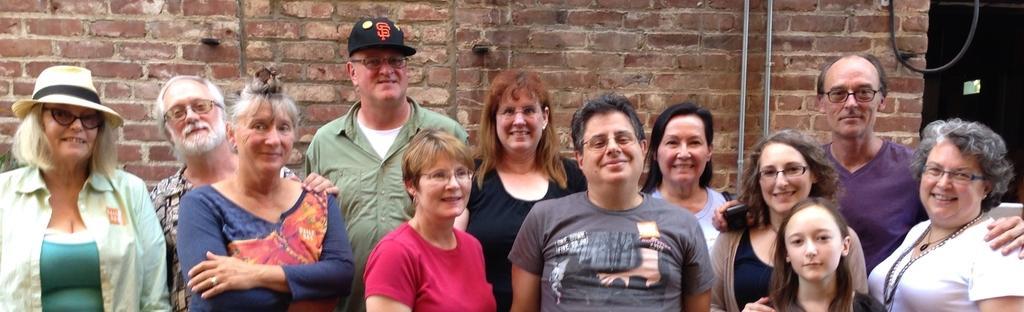How would you summarize this image in a sentence or two? In this image I can see number of people are standing and I can also see smile on their faces. I can see most of them are wearing specs and on the left side I can see two of them are wearing caps. In the background I can see the wall and on it I can see two iron pipes. On the top right side of the image I can see a black colour thing. 